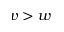Convert formula to latex. <formula><loc_0><loc_0><loc_500><loc_500>v > w</formula> 